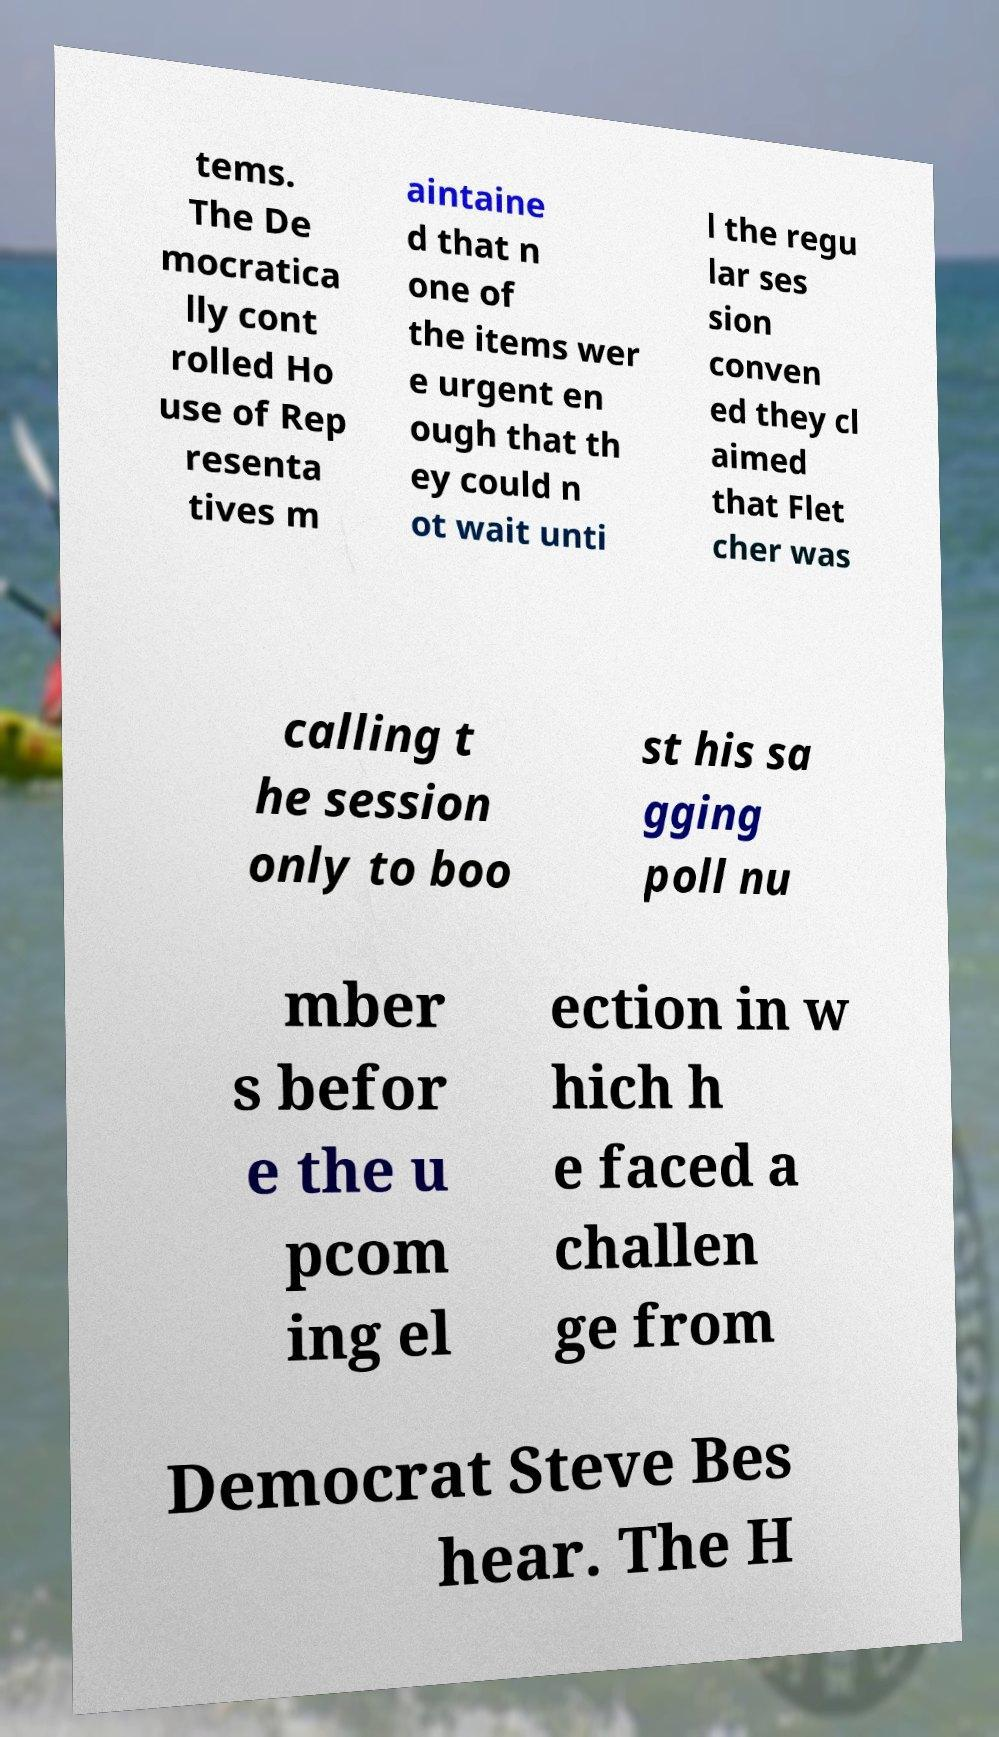Could you assist in decoding the text presented in this image and type it out clearly? tems. The De mocratica lly cont rolled Ho use of Rep resenta tives m aintaine d that n one of the items wer e urgent en ough that th ey could n ot wait unti l the regu lar ses sion conven ed they cl aimed that Flet cher was calling t he session only to boo st his sa gging poll nu mber s befor e the u pcom ing el ection in w hich h e faced a challen ge from Democrat Steve Bes hear. The H 